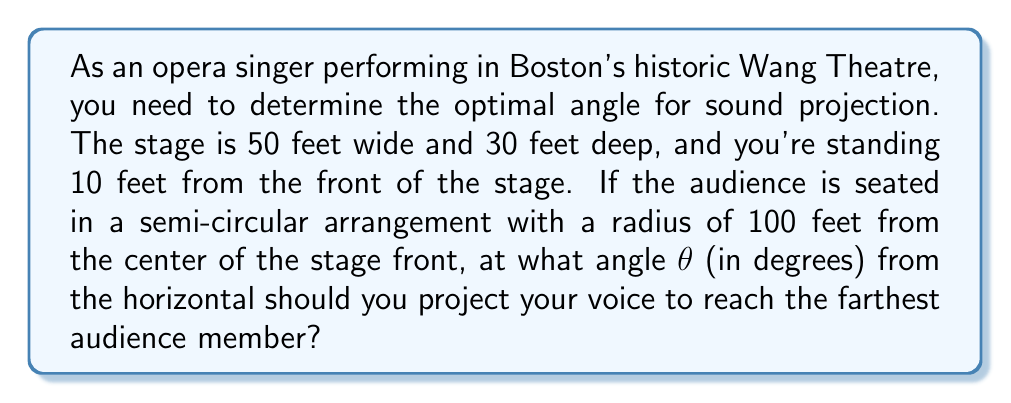Can you answer this question? Let's approach this step-by-step:

1) First, we need to determine the position of the farthest audience member. This will be at the edge of the semi-circle, 100 feet from the center of the stage front.

2) We can set up a coordinate system with the origin at the center of the stage front. The singer's position will be:
   $$(x_1, y_1) = (-15, 10)$$
   (15 feet left of center, 10 feet back from the front)

3) The farthest audience member's position will be:
   $$(x_2, y_2) = (0, 100)$$
   (directly in front of the stage, 100 feet away)

4) We can calculate the horizontal distance (d) and vertical distance (h) between these points:
   $$d = x_2 - x_1 = 0 - (-15) = 15$$
   $$h = y_2 - y_1 = 100 - 10 = 90$$

5) The angle θ can be calculated using the arctangent function:
   $$\theta = \arctan(\frac{h}{d}) = \arctan(\frac{90}{15})$$

6) Calculate this value:
   $$\theta = \arctan(6) \approx 1.4056 \text{ radians}$$

7) Convert to degrees:
   $$\theta \approx 1.4056 \times \frac{180}{\pi} \approx 80.54°$$

Therefore, the optimal angle for sound projection is approximately 80.54° from the horizontal.

[asy]
unitsize(1cm);
draw((-5,0)--(5,0), arrow=Arrow(TeXHead));
draw((0,0)--(0,10), arrow=Arrow(TeXHead));
draw((-1.5,1)--(0,10));
dot((-1.5,1));
label("Singer", (-2,1), W);
dot((0,10));
label("Audience", (0.5,10), E);
draw((-1.5,1)--(-1.5,0), dashed);
draw((-1.5,0)--(0,0), dashed);
label("15", (-0.75,0), S);
label("10", (-1.5,0.5), W);
label("90", (0,5), E);
label("$\theta$", (-1.2,1.5), NW);
[/asy]
Answer: $$80.54°$$ 